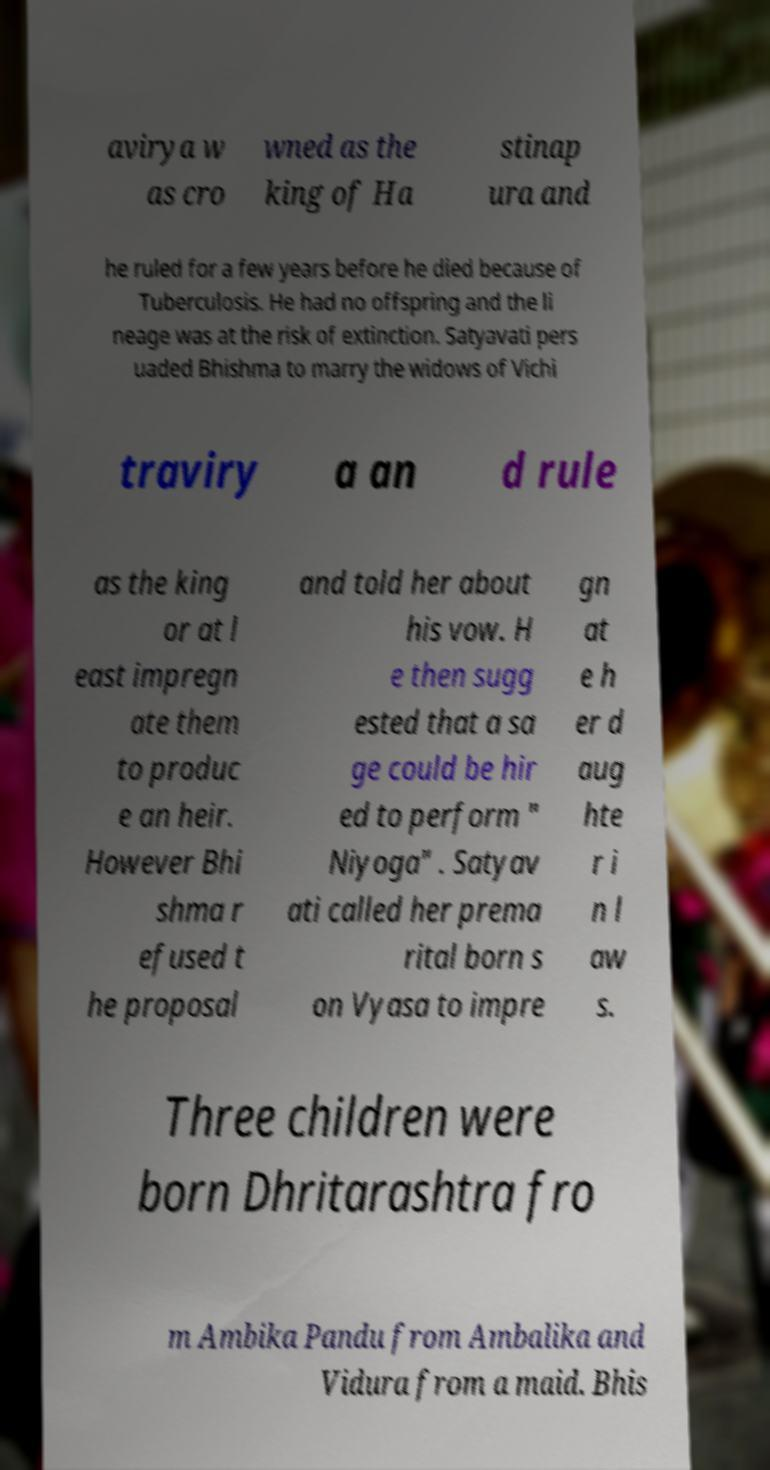Could you assist in decoding the text presented in this image and type it out clearly? avirya w as cro wned as the king of Ha stinap ura and he ruled for a few years before he died because of Tuberculosis. He had no offspring and the li neage was at the risk of extinction. Satyavati pers uaded Bhishma to marry the widows of Vichi traviry a an d rule as the king or at l east impregn ate them to produc e an heir. However Bhi shma r efused t he proposal and told her about his vow. H e then sugg ested that a sa ge could be hir ed to perform " Niyoga" . Satyav ati called her prema rital born s on Vyasa to impre gn at e h er d aug hte r i n l aw s. Three children were born Dhritarashtra fro m Ambika Pandu from Ambalika and Vidura from a maid. Bhis 